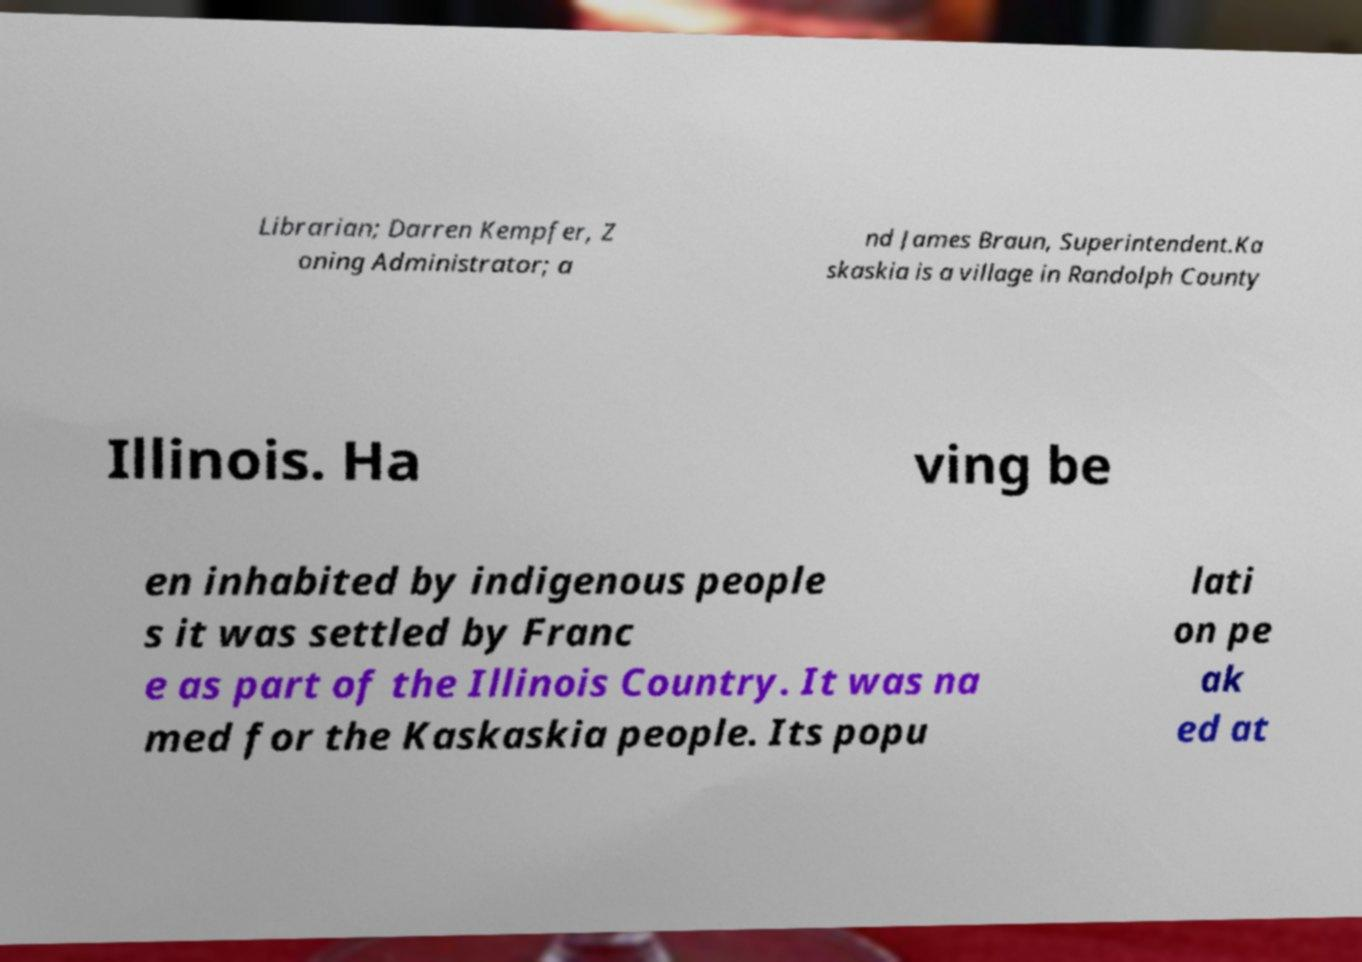Please identify and transcribe the text found in this image. Librarian; Darren Kempfer, Z oning Administrator; a nd James Braun, Superintendent.Ka skaskia is a village in Randolph County Illinois. Ha ving be en inhabited by indigenous people s it was settled by Franc e as part of the Illinois Country. It was na med for the Kaskaskia people. Its popu lati on pe ak ed at 